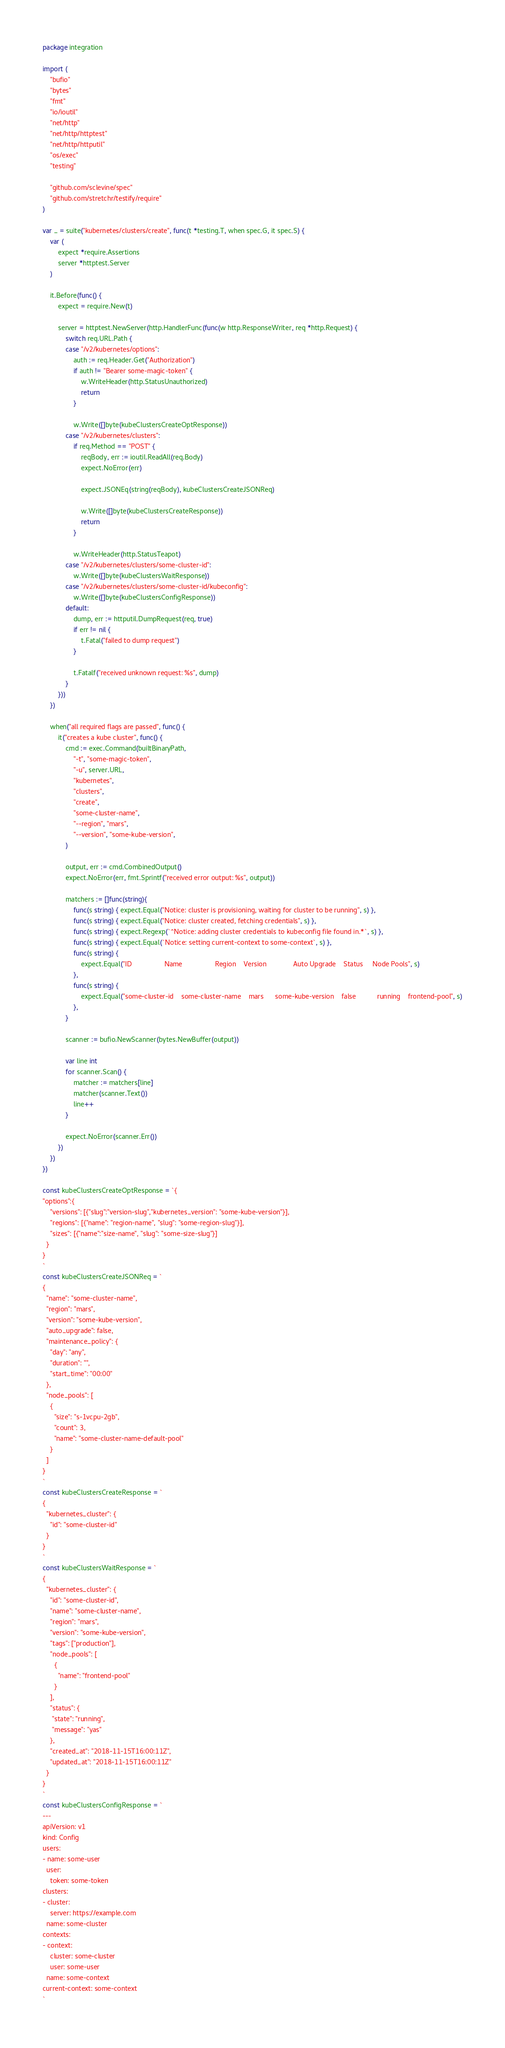Convert code to text. <code><loc_0><loc_0><loc_500><loc_500><_Go_>package integration

import (
	"bufio"
	"bytes"
	"fmt"
	"io/ioutil"
	"net/http"
	"net/http/httptest"
	"net/http/httputil"
	"os/exec"
	"testing"

	"github.com/sclevine/spec"
	"github.com/stretchr/testify/require"
)

var _ = suite("kubernetes/clusters/create", func(t *testing.T, when spec.G, it spec.S) {
	var (
		expect *require.Assertions
		server *httptest.Server
	)

	it.Before(func() {
		expect = require.New(t)

		server = httptest.NewServer(http.HandlerFunc(func(w http.ResponseWriter, req *http.Request) {
			switch req.URL.Path {
			case "/v2/kubernetes/options":
				auth := req.Header.Get("Authorization")
				if auth != "Bearer some-magic-token" {
					w.WriteHeader(http.StatusUnauthorized)
					return
				}

				w.Write([]byte(kubeClustersCreateOptResponse))
			case "/v2/kubernetes/clusters":
				if req.Method == "POST" {
					reqBody, err := ioutil.ReadAll(req.Body)
					expect.NoError(err)

					expect.JSONEq(string(reqBody), kubeClustersCreateJSONReq)

					w.Write([]byte(kubeClustersCreateResponse))
					return
				}

				w.WriteHeader(http.StatusTeapot)
			case "/v2/kubernetes/clusters/some-cluster-id":
				w.Write([]byte(kubeClustersWaitResponse))
			case "/v2/kubernetes/clusters/some-cluster-id/kubeconfig":
				w.Write([]byte(kubeClustersConfigResponse))
			default:
				dump, err := httputil.DumpRequest(req, true)
				if err != nil {
					t.Fatal("failed to dump request")
				}

				t.Fatalf("received unknown request: %s", dump)
			}
		}))
	})

	when("all required flags are passed", func() {
		it("creates a kube cluster", func() {
			cmd := exec.Command(builtBinaryPath,
				"-t", "some-magic-token",
				"-u", server.URL,
				"kubernetes",
				"clusters",
				"create",
				"some-cluster-name",
				"--region", "mars",
				"--version", "some-kube-version",
			)

			output, err := cmd.CombinedOutput()
			expect.NoError(err, fmt.Sprintf("received error output: %s", output))

			matchers := []func(string){
				func(s string) { expect.Equal("Notice: cluster is provisioning, waiting for cluster to be running", s) },
				func(s string) { expect.Equal("Notice: cluster created, fetching credentials", s) },
				func(s string) { expect.Regexp(`^Notice: adding cluster credentials to kubeconfig file found in.*`, s) },
				func(s string) { expect.Equal(`Notice: setting current-context to some-context`, s) },
				func(s string) {
					expect.Equal("ID                 Name                 Region    Version              Auto Upgrade    Status     Node Pools", s)
				},
				func(s string) {
					expect.Equal("some-cluster-id    some-cluster-name    mars      some-kube-version    false           running    frontend-pool", s)
				},
			}

			scanner := bufio.NewScanner(bytes.NewBuffer(output))

			var line int
			for scanner.Scan() {
				matcher := matchers[line]
				matcher(scanner.Text())
				line++
			}

			expect.NoError(scanner.Err())
		})
	})
})

const kubeClustersCreateOptResponse = `{
"options":{
    "versions": [{"slug":"version-slug","kubernetes_version": "some-kube-version"}],
    "regions": [{"name": "region-name", "slug": "some-region-slug"}],
    "sizes": [{"name":"size-name", "slug": "some-size-slug"}]
  }
}
`
const kubeClustersCreateJSONReq = `
{
  "name": "some-cluster-name",
  "region": "mars",
  "version": "some-kube-version",
  "auto_upgrade": false,
  "maintenance_policy": {
    "day": "any",
    "duration": "",
    "start_time": "00:00"
  },
  "node_pools": [
    {
      "size": "s-1vcpu-2gb",
      "count": 3,
      "name": "some-cluster-name-default-pool"
    }
  ]
}
`
const kubeClustersCreateResponse = `
{
  "kubernetes_cluster": {
    "id": "some-cluster-id"
  }
}
`
const kubeClustersWaitResponse = `
{
  "kubernetes_cluster": {
    "id": "some-cluster-id",
    "name": "some-cluster-name",
    "region": "mars",
    "version": "some-kube-version",
    "tags": ["production"],
    "node_pools": [
      {
        "name": "frontend-pool"
      }
    ],
    "status": {
     "state": "running",
     "message": "yas"
    },
    "created_at": "2018-11-15T16:00:11Z",
    "updated_at": "2018-11-15T16:00:11Z"
  }
}
`
const kubeClustersConfigResponse = `
---
apiVersion: v1
kind: Config
users:
- name: some-user
  user:
    token: some-token
clusters:
- cluster:
    server: https://example.com
  name: some-cluster
contexts:
- context:
    cluster: some-cluster
    user: some-user
  name: some-context
current-context: some-context
`
</code> 